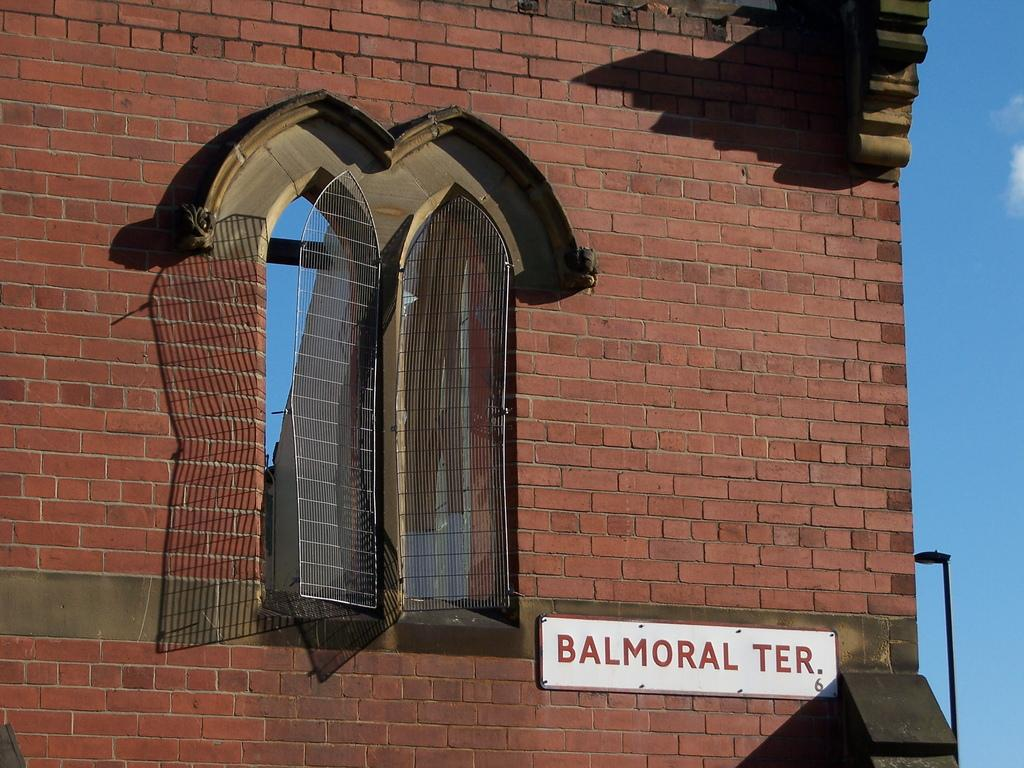What is located in the center of the image? There is a window in the center of the image. What can be seen through the window? The window provides a view of a building. What is visible in the background of the image? There is sky visible in the background of the image. How many geese are visible in the image? There are no geese present in the image. What type of peace symbol can be seen in the image? There is no peace symbol present in the image. 